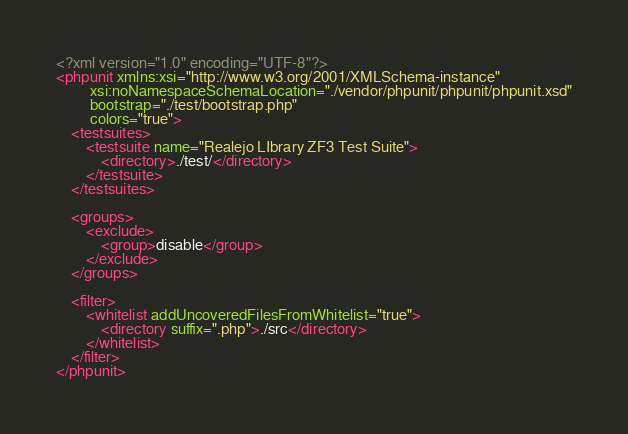<code> <loc_0><loc_0><loc_500><loc_500><_XML_><?xml version="1.0" encoding="UTF-8"?>
<phpunit xmlns:xsi="http://www.w3.org/2001/XMLSchema-instance"
         xsi:noNamespaceSchemaLocation="./vendor/phpunit/phpunit/phpunit.xsd"
         bootstrap="./test/bootstrap.php"
         colors="true">
    <testsuites>
        <testsuite name="Realejo LIbrary ZF3 Test Suite">
            <directory>./test/</directory>
        </testsuite>
    </testsuites>

    <groups>
        <exclude>
            <group>disable</group>
        </exclude>
    </groups>

    <filter>
        <whitelist addUncoveredFilesFromWhitelist="true">
            <directory suffix=".php">./src</directory>
        </whitelist>
    </filter>
</phpunit>
</code> 